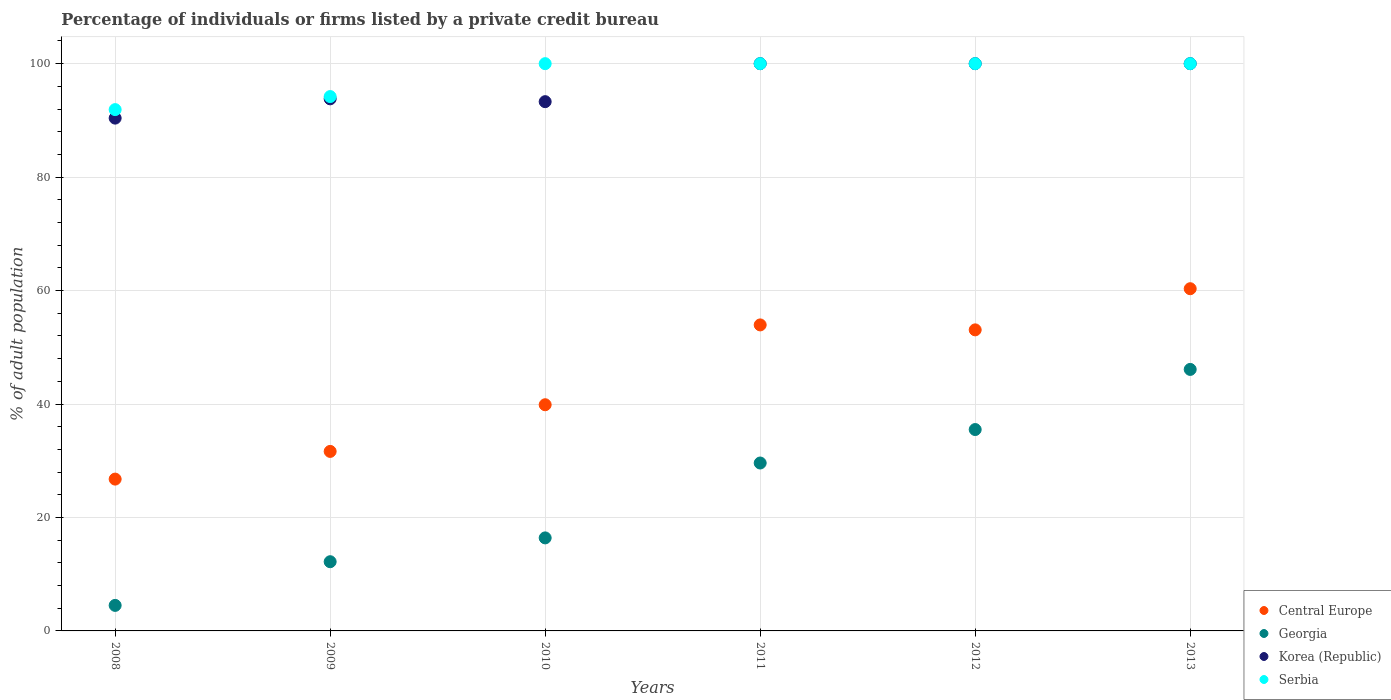How many different coloured dotlines are there?
Your response must be concise. 4. Is the number of dotlines equal to the number of legend labels?
Make the answer very short. Yes. What is the percentage of population listed by a private credit bureau in Central Europe in 2008?
Give a very brief answer. 26.76. Across all years, what is the maximum percentage of population listed by a private credit bureau in Central Europe?
Provide a succinct answer. 60.33. Across all years, what is the minimum percentage of population listed by a private credit bureau in Georgia?
Ensure brevity in your answer.  4.5. In which year was the percentage of population listed by a private credit bureau in Georgia maximum?
Give a very brief answer. 2013. What is the total percentage of population listed by a private credit bureau in Serbia in the graph?
Offer a terse response. 586.1. What is the difference between the percentage of population listed by a private credit bureau in Georgia in 2012 and that in 2013?
Make the answer very short. -10.6. What is the difference between the percentage of population listed by a private credit bureau in Georgia in 2013 and the percentage of population listed by a private credit bureau in Korea (Republic) in 2009?
Your response must be concise. -47.7. What is the average percentage of population listed by a private credit bureau in Georgia per year?
Ensure brevity in your answer.  24.05. In the year 2013, what is the difference between the percentage of population listed by a private credit bureau in Korea (Republic) and percentage of population listed by a private credit bureau in Central Europe?
Offer a terse response. 39.67. In how many years, is the percentage of population listed by a private credit bureau in Central Europe greater than 76 %?
Keep it short and to the point. 0. What is the ratio of the percentage of population listed by a private credit bureau in Korea (Republic) in 2009 to that in 2012?
Offer a terse response. 0.94. What is the difference between the highest and the lowest percentage of population listed by a private credit bureau in Korea (Republic)?
Offer a very short reply. 9.6. Is the percentage of population listed by a private credit bureau in Serbia strictly greater than the percentage of population listed by a private credit bureau in Central Europe over the years?
Keep it short and to the point. Yes. Is the percentage of population listed by a private credit bureau in Central Europe strictly less than the percentage of population listed by a private credit bureau in Serbia over the years?
Offer a very short reply. Yes. How many dotlines are there?
Offer a terse response. 4. How many years are there in the graph?
Keep it short and to the point. 6. What is the difference between two consecutive major ticks on the Y-axis?
Your answer should be compact. 20. Are the values on the major ticks of Y-axis written in scientific E-notation?
Your answer should be very brief. No. Does the graph contain any zero values?
Offer a very short reply. No. Does the graph contain grids?
Your answer should be very brief. Yes. What is the title of the graph?
Make the answer very short. Percentage of individuals or firms listed by a private credit bureau. Does "Malta" appear as one of the legend labels in the graph?
Ensure brevity in your answer.  No. What is the label or title of the X-axis?
Your response must be concise. Years. What is the label or title of the Y-axis?
Offer a terse response. % of adult population. What is the % of adult population of Central Europe in 2008?
Keep it short and to the point. 26.76. What is the % of adult population of Korea (Republic) in 2008?
Provide a succinct answer. 90.4. What is the % of adult population in Serbia in 2008?
Your answer should be compact. 91.9. What is the % of adult population of Central Europe in 2009?
Make the answer very short. 31.65. What is the % of adult population of Georgia in 2009?
Give a very brief answer. 12.2. What is the % of adult population of Korea (Republic) in 2009?
Your answer should be compact. 93.8. What is the % of adult population of Serbia in 2009?
Offer a very short reply. 94.2. What is the % of adult population in Central Europe in 2010?
Your answer should be compact. 39.87. What is the % of adult population in Korea (Republic) in 2010?
Offer a terse response. 93.3. What is the % of adult population of Serbia in 2010?
Make the answer very short. 100. What is the % of adult population of Central Europe in 2011?
Offer a very short reply. 53.95. What is the % of adult population in Georgia in 2011?
Provide a short and direct response. 29.6. What is the % of adult population of Korea (Republic) in 2011?
Provide a succinct answer. 100. What is the % of adult population of Central Europe in 2012?
Your response must be concise. 53.07. What is the % of adult population of Georgia in 2012?
Your answer should be very brief. 35.5. What is the % of adult population in Korea (Republic) in 2012?
Offer a very short reply. 100. What is the % of adult population in Central Europe in 2013?
Make the answer very short. 60.33. What is the % of adult population in Georgia in 2013?
Your answer should be very brief. 46.1. What is the % of adult population of Serbia in 2013?
Keep it short and to the point. 100. Across all years, what is the maximum % of adult population of Central Europe?
Offer a terse response. 60.33. Across all years, what is the maximum % of adult population in Georgia?
Provide a short and direct response. 46.1. Across all years, what is the maximum % of adult population of Serbia?
Ensure brevity in your answer.  100. Across all years, what is the minimum % of adult population of Central Europe?
Offer a terse response. 26.76. Across all years, what is the minimum % of adult population of Korea (Republic)?
Offer a very short reply. 90.4. Across all years, what is the minimum % of adult population of Serbia?
Ensure brevity in your answer.  91.9. What is the total % of adult population in Central Europe in the graph?
Provide a short and direct response. 265.63. What is the total % of adult population of Georgia in the graph?
Make the answer very short. 144.3. What is the total % of adult population in Korea (Republic) in the graph?
Offer a terse response. 577.5. What is the total % of adult population of Serbia in the graph?
Make the answer very short. 586.1. What is the difference between the % of adult population in Central Europe in 2008 and that in 2009?
Make the answer very short. -4.88. What is the difference between the % of adult population of Korea (Republic) in 2008 and that in 2009?
Ensure brevity in your answer.  -3.4. What is the difference between the % of adult population of Central Europe in 2008 and that in 2010?
Your answer should be compact. -13.11. What is the difference between the % of adult population in Georgia in 2008 and that in 2010?
Give a very brief answer. -11.9. What is the difference between the % of adult population of Korea (Republic) in 2008 and that in 2010?
Offer a very short reply. -2.9. What is the difference between the % of adult population of Serbia in 2008 and that in 2010?
Offer a terse response. -8.1. What is the difference between the % of adult population in Central Europe in 2008 and that in 2011?
Offer a very short reply. -27.18. What is the difference between the % of adult population of Georgia in 2008 and that in 2011?
Provide a short and direct response. -25.1. What is the difference between the % of adult population of Korea (Republic) in 2008 and that in 2011?
Provide a succinct answer. -9.6. What is the difference between the % of adult population in Central Europe in 2008 and that in 2012?
Your response must be concise. -26.31. What is the difference between the % of adult population in Georgia in 2008 and that in 2012?
Offer a terse response. -31. What is the difference between the % of adult population in Central Europe in 2008 and that in 2013?
Your answer should be very brief. -33.56. What is the difference between the % of adult population in Georgia in 2008 and that in 2013?
Provide a succinct answer. -41.6. What is the difference between the % of adult population in Serbia in 2008 and that in 2013?
Provide a succinct answer. -8.1. What is the difference between the % of adult population of Central Europe in 2009 and that in 2010?
Give a very brief answer. -8.23. What is the difference between the % of adult population of Korea (Republic) in 2009 and that in 2010?
Ensure brevity in your answer.  0.5. What is the difference between the % of adult population in Serbia in 2009 and that in 2010?
Give a very brief answer. -5.8. What is the difference between the % of adult population in Central Europe in 2009 and that in 2011?
Offer a terse response. -22.3. What is the difference between the % of adult population in Georgia in 2009 and that in 2011?
Offer a terse response. -17.4. What is the difference between the % of adult population in Korea (Republic) in 2009 and that in 2011?
Your answer should be compact. -6.2. What is the difference between the % of adult population of Serbia in 2009 and that in 2011?
Keep it short and to the point. -5.8. What is the difference between the % of adult population of Central Europe in 2009 and that in 2012?
Ensure brevity in your answer.  -21.43. What is the difference between the % of adult population of Georgia in 2009 and that in 2012?
Give a very brief answer. -23.3. What is the difference between the % of adult population in Serbia in 2009 and that in 2012?
Your answer should be compact. -5.8. What is the difference between the % of adult population in Central Europe in 2009 and that in 2013?
Give a very brief answer. -28.68. What is the difference between the % of adult population of Georgia in 2009 and that in 2013?
Provide a short and direct response. -33.9. What is the difference between the % of adult population of Korea (Republic) in 2009 and that in 2013?
Give a very brief answer. -6.2. What is the difference between the % of adult population of Serbia in 2009 and that in 2013?
Ensure brevity in your answer.  -5.8. What is the difference between the % of adult population of Central Europe in 2010 and that in 2011?
Keep it short and to the point. -14.07. What is the difference between the % of adult population of Korea (Republic) in 2010 and that in 2011?
Your answer should be compact. -6.7. What is the difference between the % of adult population of Georgia in 2010 and that in 2012?
Give a very brief answer. -19.1. What is the difference between the % of adult population of Korea (Republic) in 2010 and that in 2012?
Your answer should be very brief. -6.7. What is the difference between the % of adult population in Central Europe in 2010 and that in 2013?
Offer a very short reply. -20.45. What is the difference between the % of adult population of Georgia in 2010 and that in 2013?
Make the answer very short. -29.7. What is the difference between the % of adult population in Korea (Republic) in 2010 and that in 2013?
Make the answer very short. -6.7. What is the difference between the % of adult population in Central Europe in 2011 and that in 2012?
Offer a terse response. 0.87. What is the difference between the % of adult population of Georgia in 2011 and that in 2012?
Your response must be concise. -5.9. What is the difference between the % of adult population of Central Europe in 2011 and that in 2013?
Your answer should be very brief. -6.38. What is the difference between the % of adult population of Georgia in 2011 and that in 2013?
Offer a very short reply. -16.5. What is the difference between the % of adult population in Serbia in 2011 and that in 2013?
Your response must be concise. 0. What is the difference between the % of adult population in Central Europe in 2012 and that in 2013?
Provide a succinct answer. -7.25. What is the difference between the % of adult population in Korea (Republic) in 2012 and that in 2013?
Offer a terse response. 0. What is the difference between the % of adult population in Serbia in 2012 and that in 2013?
Offer a terse response. 0. What is the difference between the % of adult population of Central Europe in 2008 and the % of adult population of Georgia in 2009?
Your answer should be very brief. 14.56. What is the difference between the % of adult population in Central Europe in 2008 and the % of adult population in Korea (Republic) in 2009?
Give a very brief answer. -67.04. What is the difference between the % of adult population of Central Europe in 2008 and the % of adult population of Serbia in 2009?
Your answer should be compact. -67.44. What is the difference between the % of adult population in Georgia in 2008 and the % of adult population in Korea (Republic) in 2009?
Make the answer very short. -89.3. What is the difference between the % of adult population of Georgia in 2008 and the % of adult population of Serbia in 2009?
Your answer should be very brief. -89.7. What is the difference between the % of adult population of Korea (Republic) in 2008 and the % of adult population of Serbia in 2009?
Your answer should be very brief. -3.8. What is the difference between the % of adult population in Central Europe in 2008 and the % of adult population in Georgia in 2010?
Ensure brevity in your answer.  10.36. What is the difference between the % of adult population of Central Europe in 2008 and the % of adult population of Korea (Republic) in 2010?
Offer a very short reply. -66.54. What is the difference between the % of adult population in Central Europe in 2008 and the % of adult population in Serbia in 2010?
Offer a very short reply. -73.24. What is the difference between the % of adult population of Georgia in 2008 and the % of adult population of Korea (Republic) in 2010?
Give a very brief answer. -88.8. What is the difference between the % of adult population of Georgia in 2008 and the % of adult population of Serbia in 2010?
Make the answer very short. -95.5. What is the difference between the % of adult population in Central Europe in 2008 and the % of adult population in Georgia in 2011?
Give a very brief answer. -2.84. What is the difference between the % of adult population in Central Europe in 2008 and the % of adult population in Korea (Republic) in 2011?
Provide a succinct answer. -73.24. What is the difference between the % of adult population of Central Europe in 2008 and the % of adult population of Serbia in 2011?
Offer a terse response. -73.24. What is the difference between the % of adult population of Georgia in 2008 and the % of adult population of Korea (Republic) in 2011?
Ensure brevity in your answer.  -95.5. What is the difference between the % of adult population of Georgia in 2008 and the % of adult population of Serbia in 2011?
Make the answer very short. -95.5. What is the difference between the % of adult population of Central Europe in 2008 and the % of adult population of Georgia in 2012?
Give a very brief answer. -8.74. What is the difference between the % of adult population in Central Europe in 2008 and the % of adult population in Korea (Republic) in 2012?
Ensure brevity in your answer.  -73.24. What is the difference between the % of adult population of Central Europe in 2008 and the % of adult population of Serbia in 2012?
Keep it short and to the point. -73.24. What is the difference between the % of adult population in Georgia in 2008 and the % of adult population in Korea (Republic) in 2012?
Your answer should be compact. -95.5. What is the difference between the % of adult population of Georgia in 2008 and the % of adult population of Serbia in 2012?
Offer a terse response. -95.5. What is the difference between the % of adult population of Central Europe in 2008 and the % of adult population of Georgia in 2013?
Keep it short and to the point. -19.34. What is the difference between the % of adult population of Central Europe in 2008 and the % of adult population of Korea (Republic) in 2013?
Keep it short and to the point. -73.24. What is the difference between the % of adult population of Central Europe in 2008 and the % of adult population of Serbia in 2013?
Provide a succinct answer. -73.24. What is the difference between the % of adult population of Georgia in 2008 and the % of adult population of Korea (Republic) in 2013?
Make the answer very short. -95.5. What is the difference between the % of adult population of Georgia in 2008 and the % of adult population of Serbia in 2013?
Your response must be concise. -95.5. What is the difference between the % of adult population in Korea (Republic) in 2008 and the % of adult population in Serbia in 2013?
Provide a succinct answer. -9.6. What is the difference between the % of adult population of Central Europe in 2009 and the % of adult population of Georgia in 2010?
Offer a terse response. 15.25. What is the difference between the % of adult population of Central Europe in 2009 and the % of adult population of Korea (Republic) in 2010?
Make the answer very short. -61.65. What is the difference between the % of adult population of Central Europe in 2009 and the % of adult population of Serbia in 2010?
Ensure brevity in your answer.  -68.35. What is the difference between the % of adult population of Georgia in 2009 and the % of adult population of Korea (Republic) in 2010?
Keep it short and to the point. -81.1. What is the difference between the % of adult population in Georgia in 2009 and the % of adult population in Serbia in 2010?
Your answer should be very brief. -87.8. What is the difference between the % of adult population in Central Europe in 2009 and the % of adult population in Georgia in 2011?
Your response must be concise. 2.05. What is the difference between the % of adult population of Central Europe in 2009 and the % of adult population of Korea (Republic) in 2011?
Provide a succinct answer. -68.35. What is the difference between the % of adult population in Central Europe in 2009 and the % of adult population in Serbia in 2011?
Offer a terse response. -68.35. What is the difference between the % of adult population of Georgia in 2009 and the % of adult population of Korea (Republic) in 2011?
Give a very brief answer. -87.8. What is the difference between the % of adult population of Georgia in 2009 and the % of adult population of Serbia in 2011?
Your answer should be very brief. -87.8. What is the difference between the % of adult population in Korea (Republic) in 2009 and the % of adult population in Serbia in 2011?
Provide a succinct answer. -6.2. What is the difference between the % of adult population of Central Europe in 2009 and the % of adult population of Georgia in 2012?
Provide a short and direct response. -3.85. What is the difference between the % of adult population of Central Europe in 2009 and the % of adult population of Korea (Republic) in 2012?
Keep it short and to the point. -68.35. What is the difference between the % of adult population of Central Europe in 2009 and the % of adult population of Serbia in 2012?
Your answer should be compact. -68.35. What is the difference between the % of adult population of Georgia in 2009 and the % of adult population of Korea (Republic) in 2012?
Provide a succinct answer. -87.8. What is the difference between the % of adult population of Georgia in 2009 and the % of adult population of Serbia in 2012?
Keep it short and to the point. -87.8. What is the difference between the % of adult population in Korea (Republic) in 2009 and the % of adult population in Serbia in 2012?
Provide a short and direct response. -6.2. What is the difference between the % of adult population in Central Europe in 2009 and the % of adult population in Georgia in 2013?
Provide a short and direct response. -14.45. What is the difference between the % of adult population in Central Europe in 2009 and the % of adult population in Korea (Republic) in 2013?
Provide a succinct answer. -68.35. What is the difference between the % of adult population of Central Europe in 2009 and the % of adult population of Serbia in 2013?
Provide a succinct answer. -68.35. What is the difference between the % of adult population of Georgia in 2009 and the % of adult population of Korea (Republic) in 2013?
Ensure brevity in your answer.  -87.8. What is the difference between the % of adult population in Georgia in 2009 and the % of adult population in Serbia in 2013?
Offer a terse response. -87.8. What is the difference between the % of adult population in Korea (Republic) in 2009 and the % of adult population in Serbia in 2013?
Keep it short and to the point. -6.2. What is the difference between the % of adult population of Central Europe in 2010 and the % of adult population of Georgia in 2011?
Give a very brief answer. 10.27. What is the difference between the % of adult population in Central Europe in 2010 and the % of adult population in Korea (Republic) in 2011?
Keep it short and to the point. -60.13. What is the difference between the % of adult population in Central Europe in 2010 and the % of adult population in Serbia in 2011?
Give a very brief answer. -60.13. What is the difference between the % of adult population of Georgia in 2010 and the % of adult population of Korea (Republic) in 2011?
Your response must be concise. -83.6. What is the difference between the % of adult population in Georgia in 2010 and the % of adult population in Serbia in 2011?
Your answer should be very brief. -83.6. What is the difference between the % of adult population in Central Europe in 2010 and the % of adult population in Georgia in 2012?
Keep it short and to the point. 4.37. What is the difference between the % of adult population in Central Europe in 2010 and the % of adult population in Korea (Republic) in 2012?
Your answer should be very brief. -60.13. What is the difference between the % of adult population of Central Europe in 2010 and the % of adult population of Serbia in 2012?
Provide a short and direct response. -60.13. What is the difference between the % of adult population in Georgia in 2010 and the % of adult population in Korea (Republic) in 2012?
Ensure brevity in your answer.  -83.6. What is the difference between the % of adult population in Georgia in 2010 and the % of adult population in Serbia in 2012?
Your response must be concise. -83.6. What is the difference between the % of adult population in Korea (Republic) in 2010 and the % of adult population in Serbia in 2012?
Offer a terse response. -6.7. What is the difference between the % of adult population of Central Europe in 2010 and the % of adult population of Georgia in 2013?
Make the answer very short. -6.23. What is the difference between the % of adult population of Central Europe in 2010 and the % of adult population of Korea (Republic) in 2013?
Provide a succinct answer. -60.13. What is the difference between the % of adult population in Central Europe in 2010 and the % of adult population in Serbia in 2013?
Your answer should be very brief. -60.13. What is the difference between the % of adult population in Georgia in 2010 and the % of adult population in Korea (Republic) in 2013?
Your answer should be very brief. -83.6. What is the difference between the % of adult population of Georgia in 2010 and the % of adult population of Serbia in 2013?
Keep it short and to the point. -83.6. What is the difference between the % of adult population of Central Europe in 2011 and the % of adult population of Georgia in 2012?
Ensure brevity in your answer.  18.45. What is the difference between the % of adult population in Central Europe in 2011 and the % of adult population in Korea (Republic) in 2012?
Your response must be concise. -46.05. What is the difference between the % of adult population of Central Europe in 2011 and the % of adult population of Serbia in 2012?
Your answer should be compact. -46.05. What is the difference between the % of adult population in Georgia in 2011 and the % of adult population in Korea (Republic) in 2012?
Ensure brevity in your answer.  -70.4. What is the difference between the % of adult population in Georgia in 2011 and the % of adult population in Serbia in 2012?
Your answer should be very brief. -70.4. What is the difference between the % of adult population of Central Europe in 2011 and the % of adult population of Georgia in 2013?
Your answer should be very brief. 7.85. What is the difference between the % of adult population of Central Europe in 2011 and the % of adult population of Korea (Republic) in 2013?
Your answer should be very brief. -46.05. What is the difference between the % of adult population in Central Europe in 2011 and the % of adult population in Serbia in 2013?
Keep it short and to the point. -46.05. What is the difference between the % of adult population in Georgia in 2011 and the % of adult population in Korea (Republic) in 2013?
Provide a short and direct response. -70.4. What is the difference between the % of adult population in Georgia in 2011 and the % of adult population in Serbia in 2013?
Provide a short and direct response. -70.4. What is the difference between the % of adult population in Central Europe in 2012 and the % of adult population in Georgia in 2013?
Provide a short and direct response. 6.97. What is the difference between the % of adult population of Central Europe in 2012 and the % of adult population of Korea (Republic) in 2013?
Ensure brevity in your answer.  -46.93. What is the difference between the % of adult population of Central Europe in 2012 and the % of adult population of Serbia in 2013?
Provide a succinct answer. -46.93. What is the difference between the % of adult population of Georgia in 2012 and the % of adult population of Korea (Republic) in 2013?
Provide a short and direct response. -64.5. What is the difference between the % of adult population in Georgia in 2012 and the % of adult population in Serbia in 2013?
Ensure brevity in your answer.  -64.5. What is the difference between the % of adult population in Korea (Republic) in 2012 and the % of adult population in Serbia in 2013?
Offer a very short reply. 0. What is the average % of adult population of Central Europe per year?
Make the answer very short. 44.27. What is the average % of adult population of Georgia per year?
Keep it short and to the point. 24.05. What is the average % of adult population of Korea (Republic) per year?
Give a very brief answer. 96.25. What is the average % of adult population in Serbia per year?
Offer a terse response. 97.68. In the year 2008, what is the difference between the % of adult population in Central Europe and % of adult population in Georgia?
Provide a succinct answer. 22.26. In the year 2008, what is the difference between the % of adult population in Central Europe and % of adult population in Korea (Republic)?
Ensure brevity in your answer.  -63.64. In the year 2008, what is the difference between the % of adult population of Central Europe and % of adult population of Serbia?
Ensure brevity in your answer.  -65.14. In the year 2008, what is the difference between the % of adult population of Georgia and % of adult population of Korea (Republic)?
Your answer should be compact. -85.9. In the year 2008, what is the difference between the % of adult population in Georgia and % of adult population in Serbia?
Ensure brevity in your answer.  -87.4. In the year 2008, what is the difference between the % of adult population of Korea (Republic) and % of adult population of Serbia?
Your response must be concise. -1.5. In the year 2009, what is the difference between the % of adult population of Central Europe and % of adult population of Georgia?
Keep it short and to the point. 19.45. In the year 2009, what is the difference between the % of adult population of Central Europe and % of adult population of Korea (Republic)?
Make the answer very short. -62.15. In the year 2009, what is the difference between the % of adult population in Central Europe and % of adult population in Serbia?
Offer a very short reply. -62.55. In the year 2009, what is the difference between the % of adult population of Georgia and % of adult population of Korea (Republic)?
Provide a short and direct response. -81.6. In the year 2009, what is the difference between the % of adult population of Georgia and % of adult population of Serbia?
Keep it short and to the point. -82. In the year 2009, what is the difference between the % of adult population in Korea (Republic) and % of adult population in Serbia?
Give a very brief answer. -0.4. In the year 2010, what is the difference between the % of adult population of Central Europe and % of adult population of Georgia?
Provide a succinct answer. 23.47. In the year 2010, what is the difference between the % of adult population in Central Europe and % of adult population in Korea (Republic)?
Offer a terse response. -53.43. In the year 2010, what is the difference between the % of adult population of Central Europe and % of adult population of Serbia?
Offer a very short reply. -60.13. In the year 2010, what is the difference between the % of adult population in Georgia and % of adult population in Korea (Republic)?
Ensure brevity in your answer.  -76.9. In the year 2010, what is the difference between the % of adult population in Georgia and % of adult population in Serbia?
Provide a succinct answer. -83.6. In the year 2010, what is the difference between the % of adult population of Korea (Republic) and % of adult population of Serbia?
Give a very brief answer. -6.7. In the year 2011, what is the difference between the % of adult population of Central Europe and % of adult population of Georgia?
Offer a very short reply. 24.35. In the year 2011, what is the difference between the % of adult population of Central Europe and % of adult population of Korea (Republic)?
Make the answer very short. -46.05. In the year 2011, what is the difference between the % of adult population in Central Europe and % of adult population in Serbia?
Give a very brief answer. -46.05. In the year 2011, what is the difference between the % of adult population of Georgia and % of adult population of Korea (Republic)?
Provide a short and direct response. -70.4. In the year 2011, what is the difference between the % of adult population of Georgia and % of adult population of Serbia?
Make the answer very short. -70.4. In the year 2012, what is the difference between the % of adult population in Central Europe and % of adult population in Georgia?
Give a very brief answer. 17.57. In the year 2012, what is the difference between the % of adult population in Central Europe and % of adult population in Korea (Republic)?
Your answer should be compact. -46.93. In the year 2012, what is the difference between the % of adult population of Central Europe and % of adult population of Serbia?
Provide a succinct answer. -46.93. In the year 2012, what is the difference between the % of adult population of Georgia and % of adult population of Korea (Republic)?
Your response must be concise. -64.5. In the year 2012, what is the difference between the % of adult population of Georgia and % of adult population of Serbia?
Keep it short and to the point. -64.5. In the year 2012, what is the difference between the % of adult population in Korea (Republic) and % of adult population in Serbia?
Offer a terse response. 0. In the year 2013, what is the difference between the % of adult population of Central Europe and % of adult population of Georgia?
Your response must be concise. 14.23. In the year 2013, what is the difference between the % of adult population in Central Europe and % of adult population in Korea (Republic)?
Ensure brevity in your answer.  -39.67. In the year 2013, what is the difference between the % of adult population of Central Europe and % of adult population of Serbia?
Your answer should be very brief. -39.67. In the year 2013, what is the difference between the % of adult population of Georgia and % of adult population of Korea (Republic)?
Your response must be concise. -53.9. In the year 2013, what is the difference between the % of adult population in Georgia and % of adult population in Serbia?
Offer a terse response. -53.9. In the year 2013, what is the difference between the % of adult population in Korea (Republic) and % of adult population in Serbia?
Keep it short and to the point. 0. What is the ratio of the % of adult population in Central Europe in 2008 to that in 2009?
Give a very brief answer. 0.85. What is the ratio of the % of adult population in Georgia in 2008 to that in 2009?
Keep it short and to the point. 0.37. What is the ratio of the % of adult population in Korea (Republic) in 2008 to that in 2009?
Give a very brief answer. 0.96. What is the ratio of the % of adult population of Serbia in 2008 to that in 2009?
Your response must be concise. 0.98. What is the ratio of the % of adult population in Central Europe in 2008 to that in 2010?
Keep it short and to the point. 0.67. What is the ratio of the % of adult population in Georgia in 2008 to that in 2010?
Ensure brevity in your answer.  0.27. What is the ratio of the % of adult population of Korea (Republic) in 2008 to that in 2010?
Offer a very short reply. 0.97. What is the ratio of the % of adult population in Serbia in 2008 to that in 2010?
Your response must be concise. 0.92. What is the ratio of the % of adult population of Central Europe in 2008 to that in 2011?
Give a very brief answer. 0.5. What is the ratio of the % of adult population of Georgia in 2008 to that in 2011?
Make the answer very short. 0.15. What is the ratio of the % of adult population of Korea (Republic) in 2008 to that in 2011?
Give a very brief answer. 0.9. What is the ratio of the % of adult population of Serbia in 2008 to that in 2011?
Keep it short and to the point. 0.92. What is the ratio of the % of adult population of Central Europe in 2008 to that in 2012?
Offer a very short reply. 0.5. What is the ratio of the % of adult population in Georgia in 2008 to that in 2012?
Offer a very short reply. 0.13. What is the ratio of the % of adult population of Korea (Republic) in 2008 to that in 2012?
Your answer should be compact. 0.9. What is the ratio of the % of adult population of Serbia in 2008 to that in 2012?
Ensure brevity in your answer.  0.92. What is the ratio of the % of adult population in Central Europe in 2008 to that in 2013?
Give a very brief answer. 0.44. What is the ratio of the % of adult population in Georgia in 2008 to that in 2013?
Your response must be concise. 0.1. What is the ratio of the % of adult population of Korea (Republic) in 2008 to that in 2013?
Provide a succinct answer. 0.9. What is the ratio of the % of adult population in Serbia in 2008 to that in 2013?
Provide a short and direct response. 0.92. What is the ratio of the % of adult population of Central Europe in 2009 to that in 2010?
Your answer should be very brief. 0.79. What is the ratio of the % of adult population in Georgia in 2009 to that in 2010?
Your answer should be compact. 0.74. What is the ratio of the % of adult population of Korea (Republic) in 2009 to that in 2010?
Give a very brief answer. 1.01. What is the ratio of the % of adult population in Serbia in 2009 to that in 2010?
Make the answer very short. 0.94. What is the ratio of the % of adult population in Central Europe in 2009 to that in 2011?
Ensure brevity in your answer.  0.59. What is the ratio of the % of adult population of Georgia in 2009 to that in 2011?
Your answer should be compact. 0.41. What is the ratio of the % of adult population in Korea (Republic) in 2009 to that in 2011?
Ensure brevity in your answer.  0.94. What is the ratio of the % of adult population in Serbia in 2009 to that in 2011?
Make the answer very short. 0.94. What is the ratio of the % of adult population in Central Europe in 2009 to that in 2012?
Ensure brevity in your answer.  0.6. What is the ratio of the % of adult population of Georgia in 2009 to that in 2012?
Provide a short and direct response. 0.34. What is the ratio of the % of adult population of Korea (Republic) in 2009 to that in 2012?
Provide a succinct answer. 0.94. What is the ratio of the % of adult population of Serbia in 2009 to that in 2012?
Provide a short and direct response. 0.94. What is the ratio of the % of adult population of Central Europe in 2009 to that in 2013?
Your answer should be very brief. 0.52. What is the ratio of the % of adult population in Georgia in 2009 to that in 2013?
Make the answer very short. 0.26. What is the ratio of the % of adult population of Korea (Republic) in 2009 to that in 2013?
Give a very brief answer. 0.94. What is the ratio of the % of adult population of Serbia in 2009 to that in 2013?
Make the answer very short. 0.94. What is the ratio of the % of adult population in Central Europe in 2010 to that in 2011?
Offer a terse response. 0.74. What is the ratio of the % of adult population of Georgia in 2010 to that in 2011?
Your response must be concise. 0.55. What is the ratio of the % of adult population in Korea (Republic) in 2010 to that in 2011?
Your response must be concise. 0.93. What is the ratio of the % of adult population in Serbia in 2010 to that in 2011?
Make the answer very short. 1. What is the ratio of the % of adult population in Central Europe in 2010 to that in 2012?
Provide a short and direct response. 0.75. What is the ratio of the % of adult population of Georgia in 2010 to that in 2012?
Offer a very short reply. 0.46. What is the ratio of the % of adult population in Korea (Republic) in 2010 to that in 2012?
Keep it short and to the point. 0.93. What is the ratio of the % of adult population in Serbia in 2010 to that in 2012?
Your response must be concise. 1. What is the ratio of the % of adult population of Central Europe in 2010 to that in 2013?
Ensure brevity in your answer.  0.66. What is the ratio of the % of adult population of Georgia in 2010 to that in 2013?
Your answer should be compact. 0.36. What is the ratio of the % of adult population in Korea (Republic) in 2010 to that in 2013?
Your response must be concise. 0.93. What is the ratio of the % of adult population in Serbia in 2010 to that in 2013?
Keep it short and to the point. 1. What is the ratio of the % of adult population in Central Europe in 2011 to that in 2012?
Provide a short and direct response. 1.02. What is the ratio of the % of adult population of Georgia in 2011 to that in 2012?
Offer a very short reply. 0.83. What is the ratio of the % of adult population of Central Europe in 2011 to that in 2013?
Your answer should be very brief. 0.89. What is the ratio of the % of adult population in Georgia in 2011 to that in 2013?
Make the answer very short. 0.64. What is the ratio of the % of adult population of Central Europe in 2012 to that in 2013?
Keep it short and to the point. 0.88. What is the ratio of the % of adult population of Georgia in 2012 to that in 2013?
Keep it short and to the point. 0.77. What is the ratio of the % of adult population in Korea (Republic) in 2012 to that in 2013?
Your response must be concise. 1. What is the ratio of the % of adult population of Serbia in 2012 to that in 2013?
Provide a succinct answer. 1. What is the difference between the highest and the second highest % of adult population of Central Europe?
Offer a very short reply. 6.38. What is the difference between the highest and the second highest % of adult population in Korea (Republic)?
Make the answer very short. 0. What is the difference between the highest and the lowest % of adult population in Central Europe?
Provide a succinct answer. 33.56. What is the difference between the highest and the lowest % of adult population of Georgia?
Provide a succinct answer. 41.6. What is the difference between the highest and the lowest % of adult population of Serbia?
Offer a terse response. 8.1. 